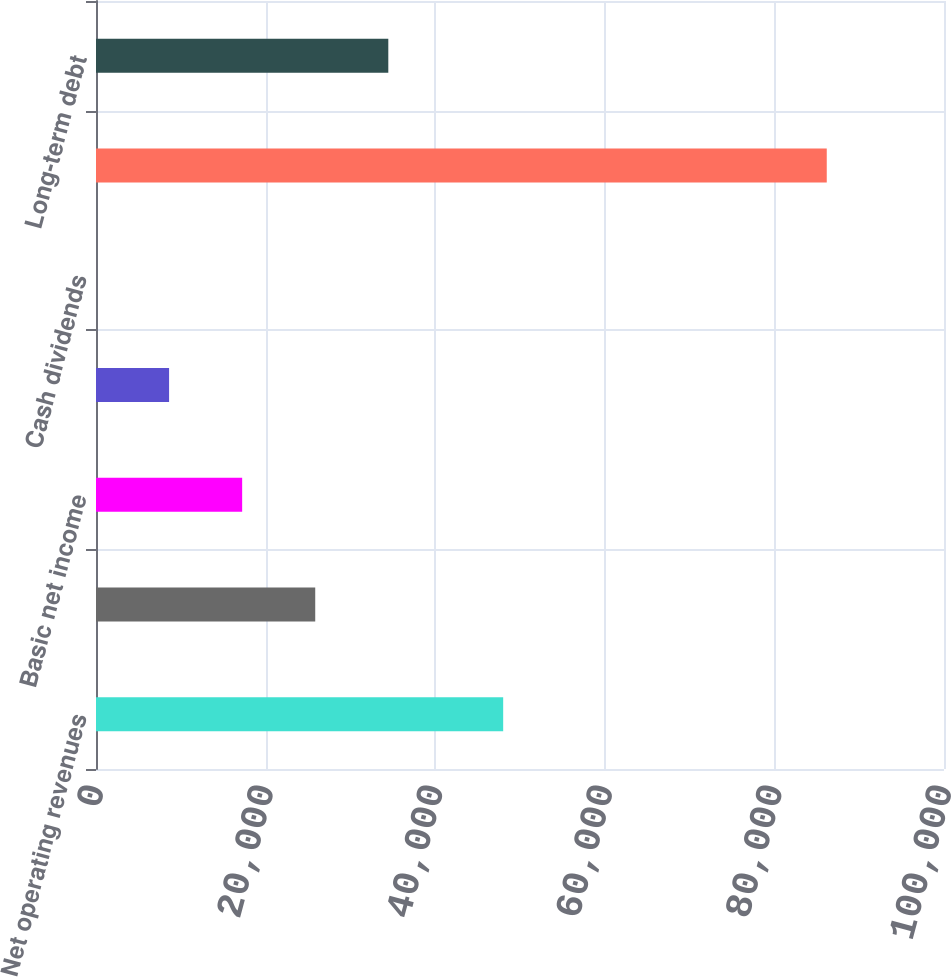<chart> <loc_0><loc_0><loc_500><loc_500><bar_chart><fcel>Net operating revenues<fcel>Net income attributable to<fcel>Basic net income<fcel>Diluted net income<fcel>Cash dividends<fcel>Total assets<fcel>Long-term debt<nl><fcel>48017<fcel>25852.9<fcel>17235.6<fcel>8618.32<fcel>1.02<fcel>86174<fcel>34470.2<nl></chart> 